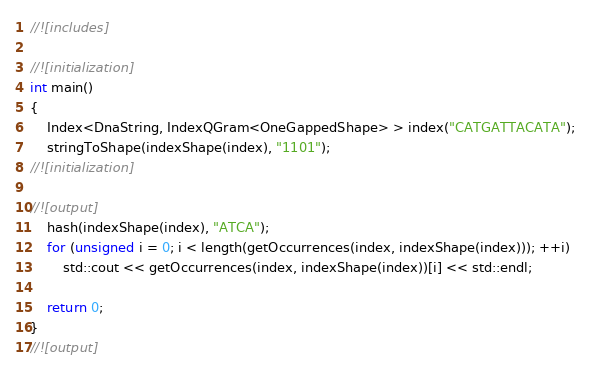<code> <loc_0><loc_0><loc_500><loc_500><_C++_>//![includes]

//![initialization]
int main()
{
    Index<DnaString, IndexQGram<OneGappedShape> > index("CATGATTACATA");
    stringToShape(indexShape(index), "1101");
//![initialization]

//![output]
    hash(indexShape(index), "ATCA");
    for (unsigned i = 0; i < length(getOccurrences(index, indexShape(index))); ++i)
        std::cout << getOccurrences(index, indexShape(index))[i] << std::endl;

    return 0;
}
//![output]
</code> 